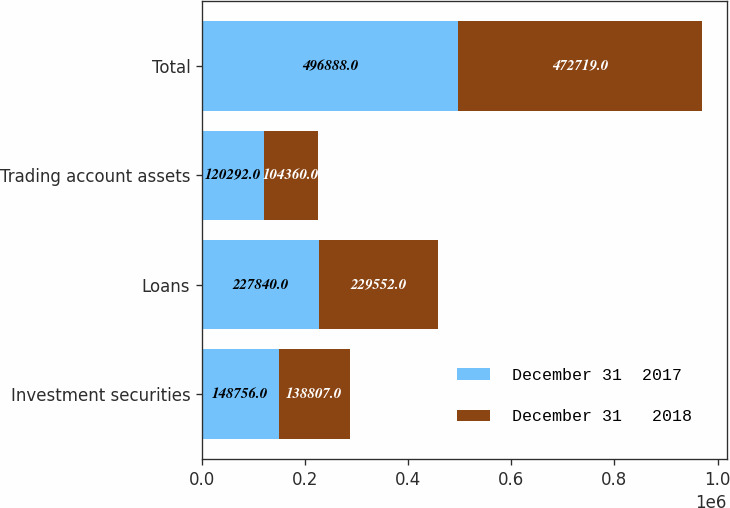Convert chart to OTSL. <chart><loc_0><loc_0><loc_500><loc_500><stacked_bar_chart><ecel><fcel>Investment securities<fcel>Loans<fcel>Trading account assets<fcel>Total<nl><fcel>December 31  2017<fcel>148756<fcel>227840<fcel>120292<fcel>496888<nl><fcel>December 31   2018<fcel>138807<fcel>229552<fcel>104360<fcel>472719<nl></chart> 